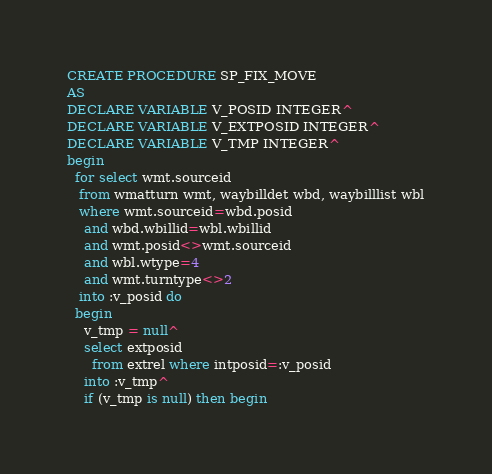<code> <loc_0><loc_0><loc_500><loc_500><_SQL_>CREATE PROCEDURE SP_FIX_MOVE 
AS
DECLARE VARIABLE V_POSID INTEGER^
DECLARE VARIABLE V_EXTPOSID INTEGER^
DECLARE VARIABLE V_TMP INTEGER^
begin
  for select wmt.sourceid
   from wmatturn wmt, waybilldet wbd, waybilllist wbl
   where wmt.sourceid=wbd.posid
    and wbd.wbillid=wbl.wbillid
    and wmt.posid<>wmt.sourceid
    and wbl.wtype=4
    and wmt.turntype<>2
   into :v_posid do
  begin
    v_tmp = null^
    select extposid
      from extrel where intposid=:v_posid
    into :v_tmp^
    if (v_tmp is null) then begin</code> 